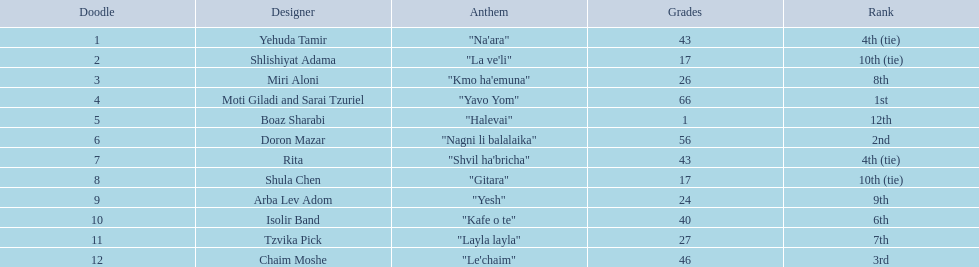How many artists are there? Yehuda Tamir, Shlishiyat Adama, Miri Aloni, Moti Giladi and Sarai Tzuriel, Boaz Sharabi, Doron Mazar, Rita, Shula Chen, Arba Lev Adom, Isolir Band, Tzvika Pick, Chaim Moshe. What is the least amount of points awarded? 1. Who was the artist awarded those points? Boaz Sharabi. 